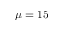<formula> <loc_0><loc_0><loc_500><loc_500>\mu = 1 5</formula> 